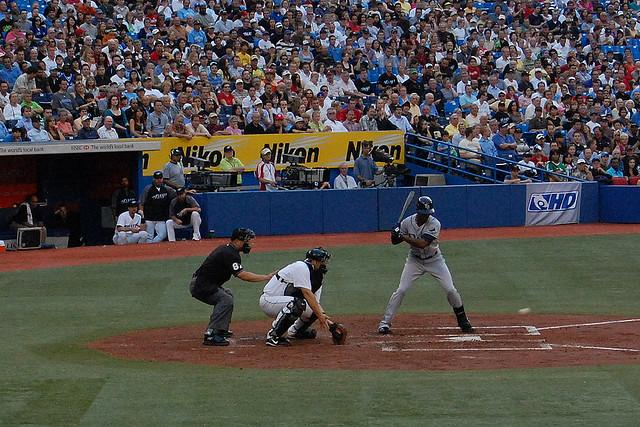What kind of product does the sponsor with the yellow background offer? camera 